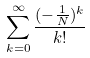<formula> <loc_0><loc_0><loc_500><loc_500>\sum _ { k = 0 } ^ { \infty } \frac { ( - \frac { 1 } { N } ) ^ { k } } { k ! }</formula> 